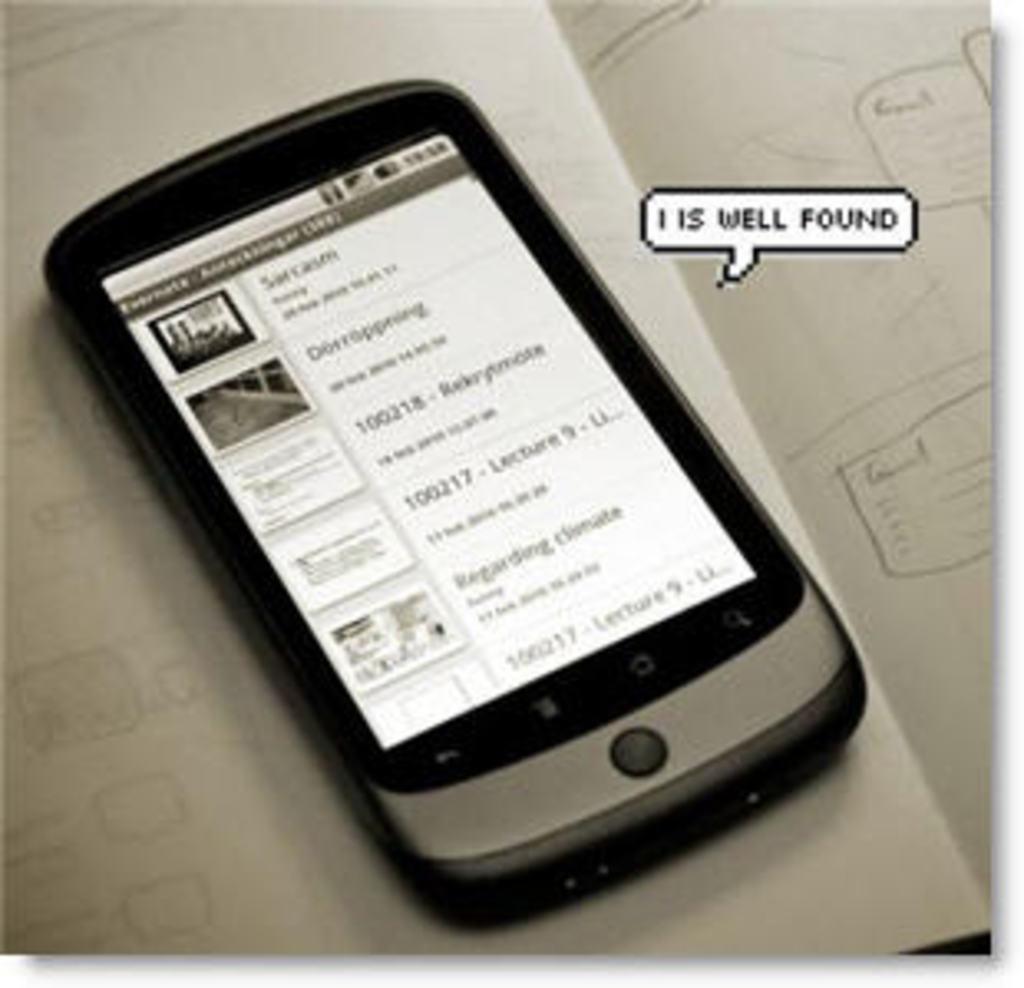Please provide a concise description of this image. In this image I can see a mobile phone. I can also see some text on the screen. On the right side, I can see some text. In the background, I can see a book. 